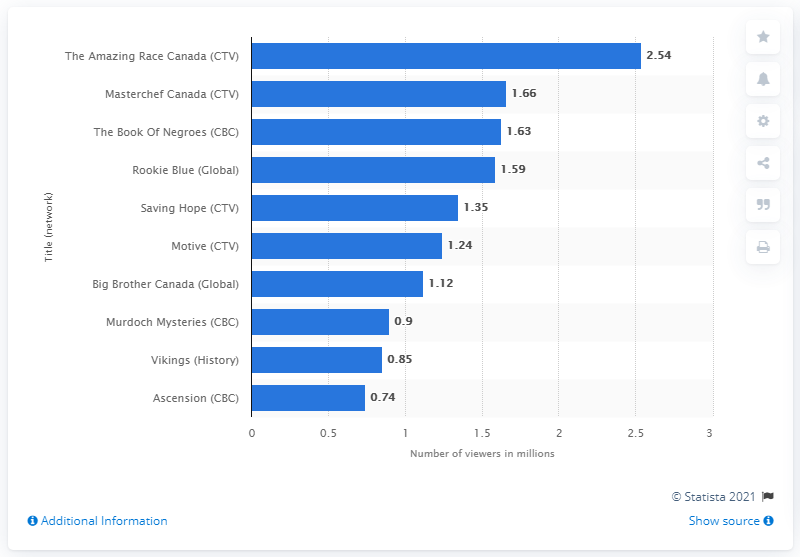Identify some key points in this picture. In 2015, Rookie Blue was watched by 1.59 million viewers on Global. 